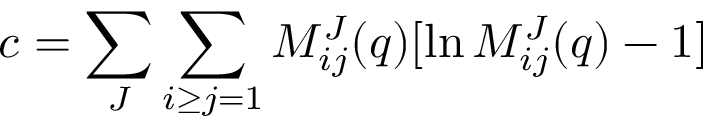Convert formula to latex. <formula><loc_0><loc_0><loc_500><loc_500>c = \sum _ { J } \sum _ { i \geq j = 1 } M _ { i j } ^ { J } ( q ) [ \ln M _ { i j } ^ { J } ( q ) - 1 ]</formula> 